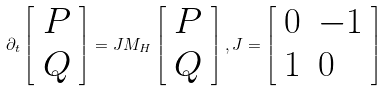<formula> <loc_0><loc_0><loc_500><loc_500>\partial _ { t } \left [ \begin{array} [ c ] { l } P \\ Q \end{array} \right ] = J M _ { H } \left [ \begin{array} [ c ] { l } P \\ Q \end{array} \right ] , J = \left [ \begin{array} [ c ] { l l } 0 & - 1 \\ 1 & 0 \end{array} \right ]</formula> 